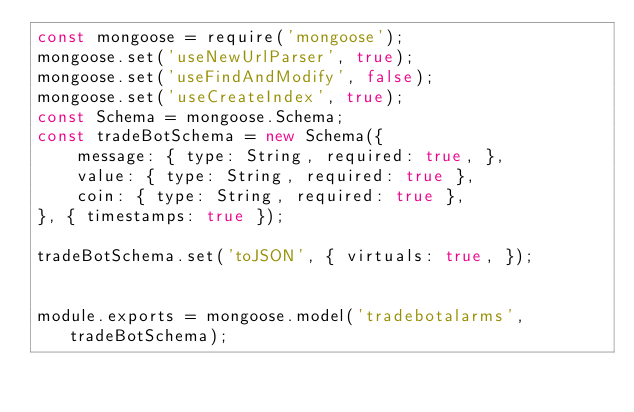Convert code to text. <code><loc_0><loc_0><loc_500><loc_500><_JavaScript_>const mongoose = require('mongoose');
mongoose.set('useNewUrlParser', true);
mongoose.set('useFindAndModify', false);
mongoose.set('useCreateIndex', true);
const Schema = mongoose.Schema;
const tradeBotSchema = new Schema({
    message: { type: String, required: true, },
    value: { type: String, required: true },
    coin: { type: String, required: true },
}, { timestamps: true });

tradeBotSchema.set('toJSON', { virtuals: true, });


module.exports = mongoose.model('tradebotalarms', tradeBotSchema);</code> 